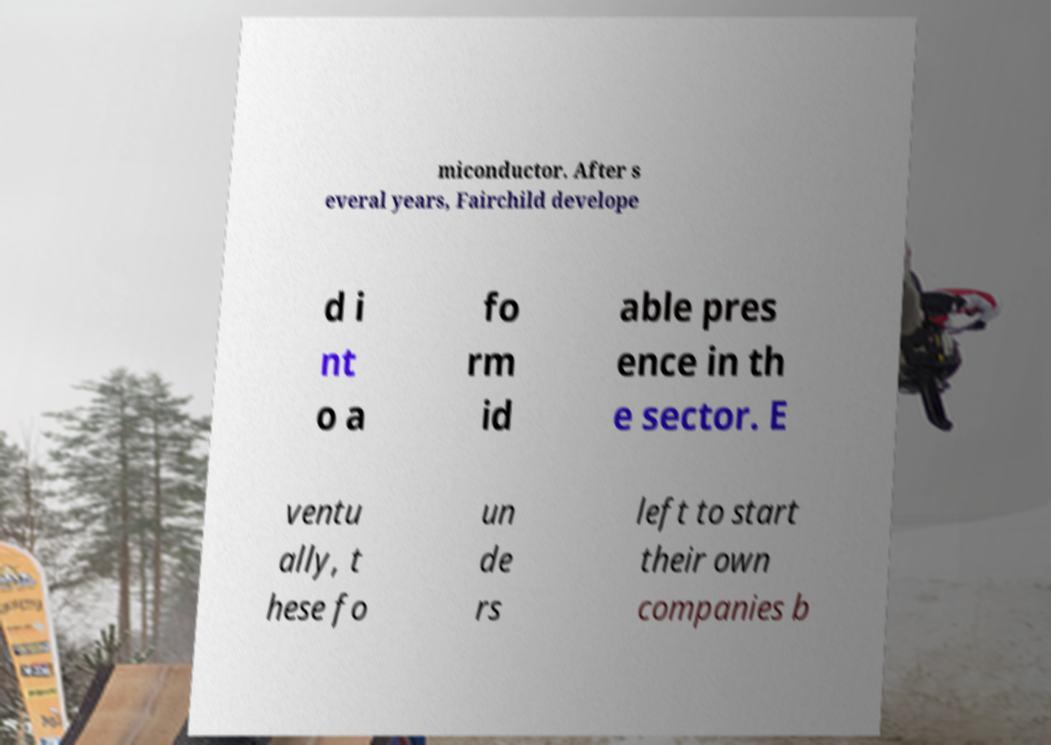Can you accurately transcribe the text from the provided image for me? miconductor. After s everal years, Fairchild develope d i nt o a fo rm id able pres ence in th e sector. E ventu ally, t hese fo un de rs left to start their own companies b 